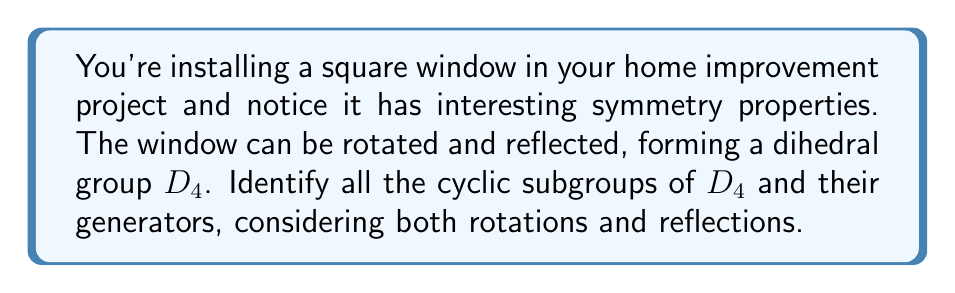Could you help me with this problem? Let's approach this step-by-step:

1) First, recall that the dihedral group $D_4$ has 8 elements:
   - Four rotations: $e$ (identity), $r$ (90° clockwise), $r^2$ (180°), $r^3$ (270° clockwise)
   - Four reflections: $s$ (vertical), $sr$ (diagonal), $sr^2$ (horizontal), $sr^3$ (other diagonal)

2) To find cyclic subgroups, we need to consider each element and see what subgroup it generates.

3) Rotations:
   - $\langle e \rangle = \{e\}$ (trivial subgroup)
   - $\langle r \rangle = \{e, r, r^2, r^3\}$ (order 4)
   - $\langle r^2 \rangle = \{e, r^2\}$ (order 2)
   - $\langle r^3 \rangle = \{e, r, r^2, r^3\}$ (same as $\langle r \rangle$)

4) Reflections:
   - $\langle s \rangle = \{e, s\}$ (order 2)
   - $\langle sr \rangle = \{e, sr\}$ (order 2)
   - $\langle sr^2 \rangle = \{e, sr^2\}$ (order 2)
   - $\langle sr^3 \rangle = \{e, sr^3\}$ (order 2)

5) Note that all reflections generate subgroups of order 2, as reflecting twice brings you back to the starting position.

6) We can visualize these subgroups using Asymptote:

[asy]
import geometry;

size(200);

pair A=(-1,-1), B=(1,-1), C=(1,1), D=(-1,1);
draw(A--B--C--D--cycle);

draw((-1.2,0)--(1.2,0), arrow=Arrow(TeXHead));
draw((0,-1.2)--(0,1.2), arrow=Arrow(TeXHead));
draw((-1.2,-1.2)--(1.2,1.2), dashed);
draw((-1.2,1.2)--(1.2,-1.2), dashed);

label("$e$", (0,0), SW);
label("$r$", (0.7,0.7), NE);
label("$r^2$", (-0.7,-0.7), SW);
label("$r^3$", (-0.7,0.7), NW);
label("$s$", (1.3,0), E);
label("$sr$", (0,1.3), N);
label("$sr^2$", (-1.3,0), W);
label("$sr^3$", (0,-1.3), S);
[/asy]

This diagram shows the elements of $D_4$ and how they act on the square window.
Answer: The cyclic subgroups of $D_4$ are:
1) $\{e\}$ (trivial subgroup)
2) $\{e, r, r^2, r^3\}$ generated by $r$ or $r^3$
3) $\{e, r^2\}$ generated by $r^2$
4) $\{e, s\}$ generated by $s$
5) $\{e, sr\}$ generated by $sr$
6) $\{e, sr^2\}$ generated by $sr^2$
7) $\{e, sr^3\}$ generated by $sr^3$ 